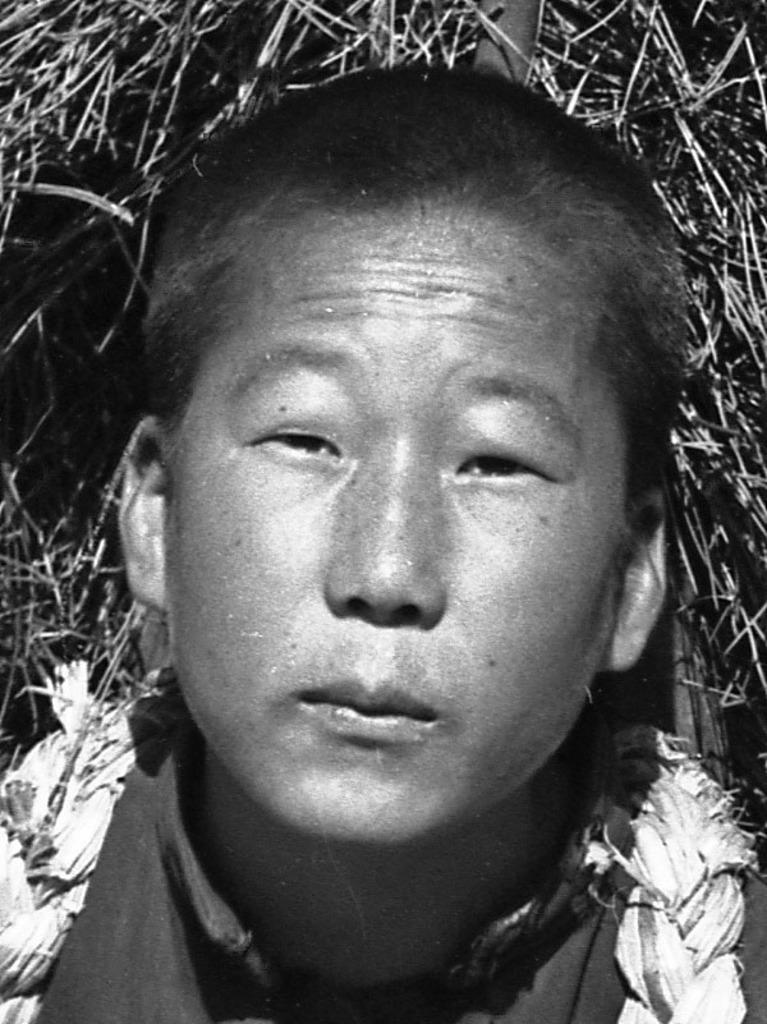What type of picture is in the image? There is a black and white picture of a person in the image. What can be seen in the background of the picture? The background of the image contains dry sticks. What type of expansion is visible in the image? There is no expansion visible in the image; it contains a black and white picture of a person and a background with dry sticks. 